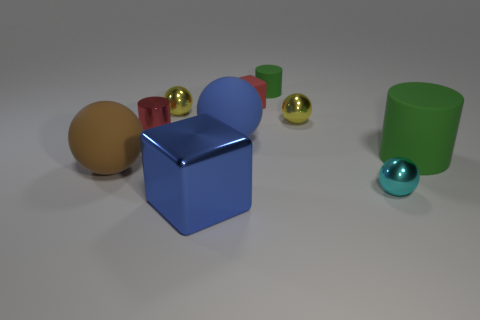Subtract all cyan balls. How many balls are left? 4 Subtract all cubes. How many objects are left? 8 Subtract all yellow balls. How many balls are left? 3 Subtract 0 green cubes. How many objects are left? 10 Subtract 2 balls. How many balls are left? 3 Subtract all blue cylinders. Subtract all purple cubes. How many cylinders are left? 3 Subtract all green cylinders. How many blue balls are left? 1 Subtract all large purple metallic cylinders. Subtract all tiny cyan metal spheres. How many objects are left? 9 Add 7 matte blocks. How many matte blocks are left? 8 Add 4 large red metallic cylinders. How many large red metallic cylinders exist? 4 